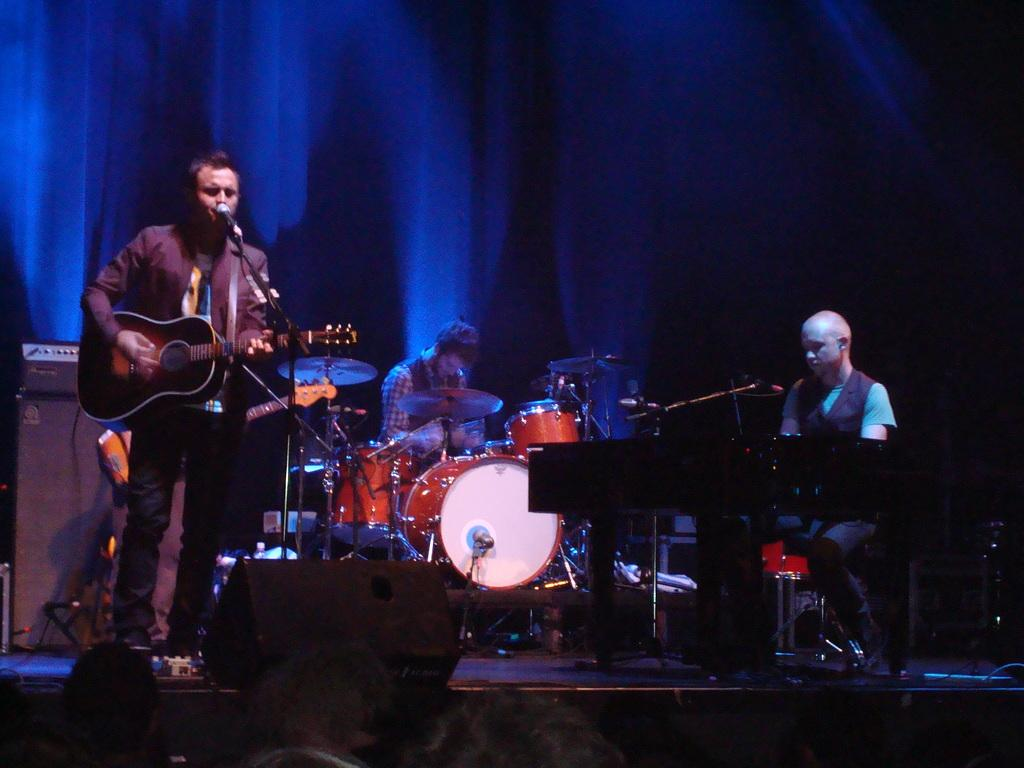What is the person on the left side of the image doing? The person on the left side of the image is wearing a guitar. What is the person on the right side of the image doing? The person on the right side of the image is playing a keyboard. Can you describe the person in the background of the image? The person in the background of the image is playing drums. Where is the aunt's mitten in the image? There is no mention of an aunt or a mitten in the image; the focus is on the people playing musical instruments. How many ducks are visible in the image? There are no ducks present in the image. 